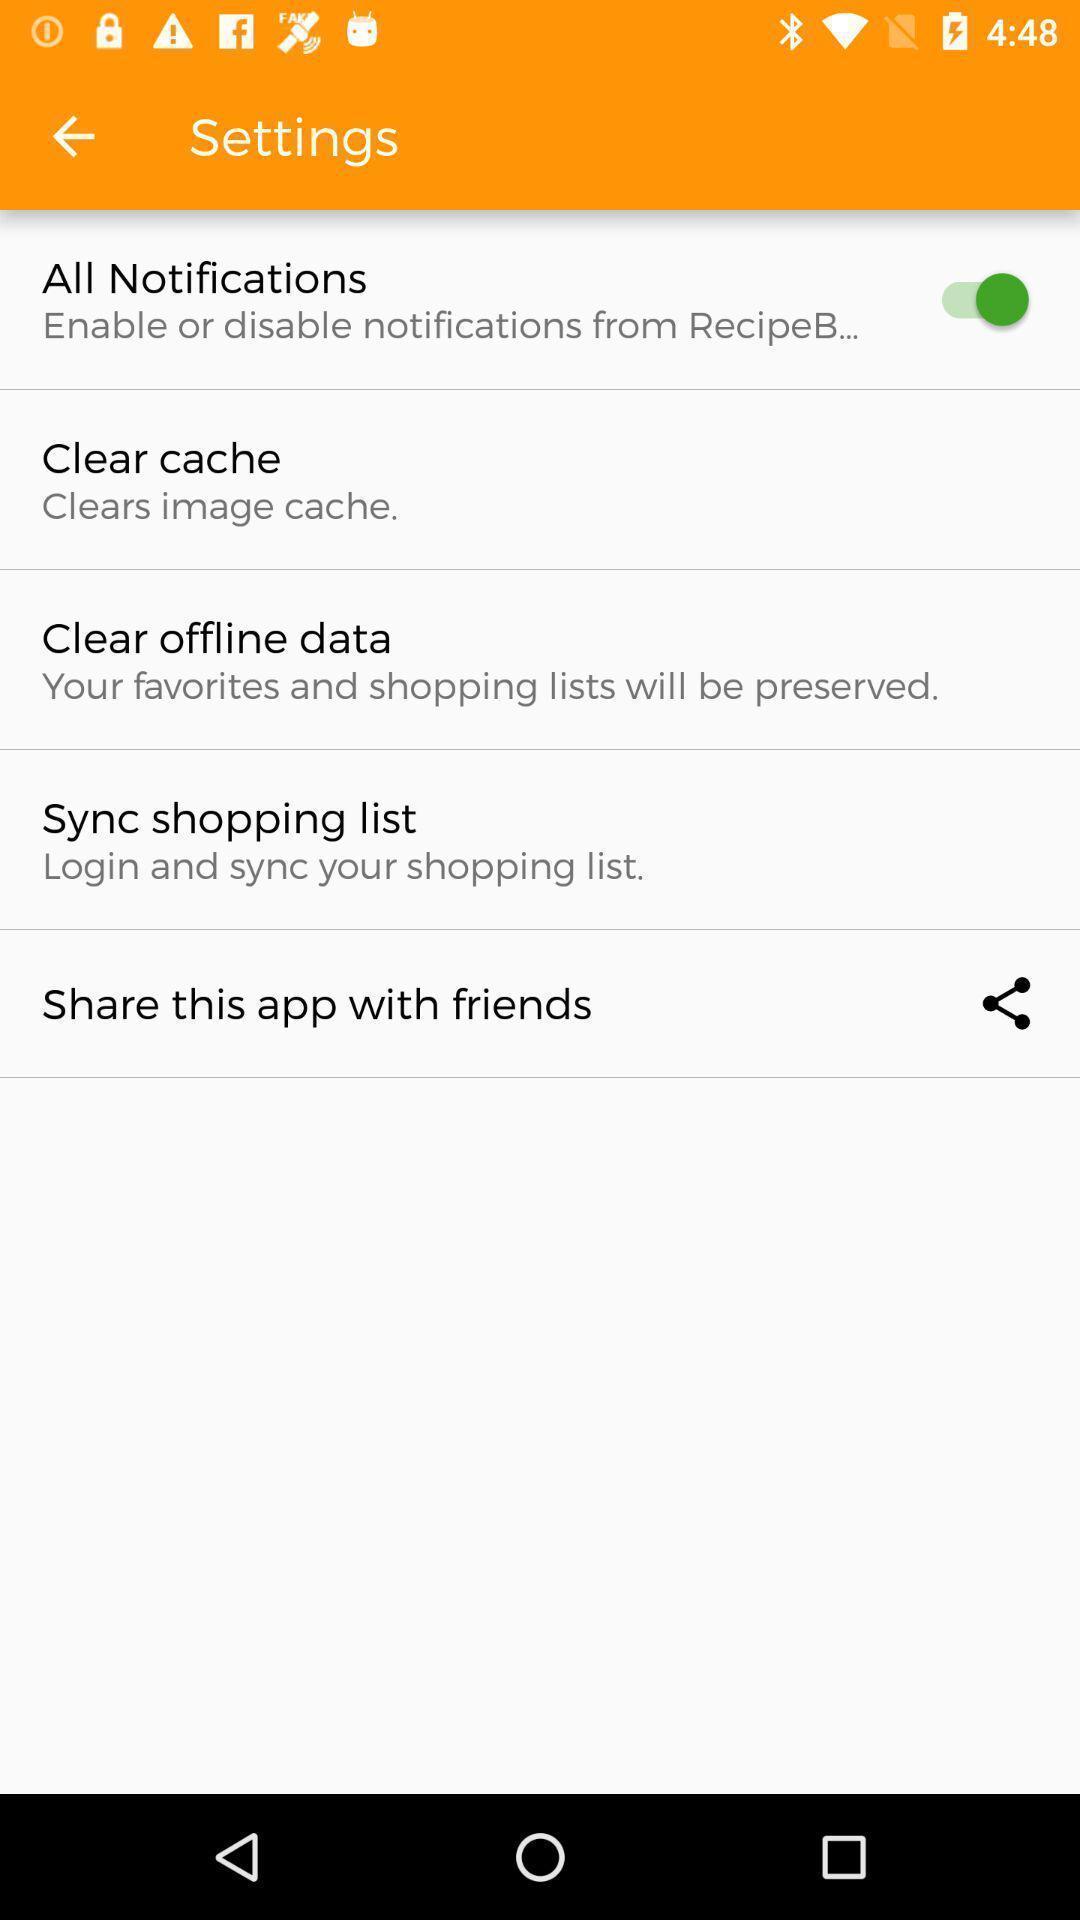Please provide a description for this image. Screen displaying the settings page. 